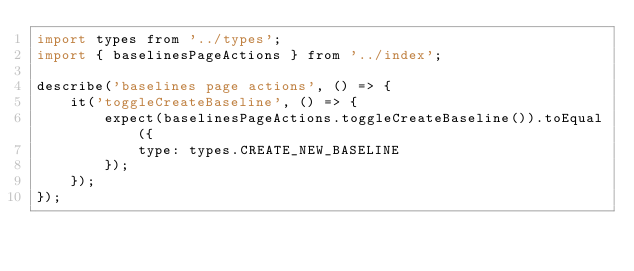<code> <loc_0><loc_0><loc_500><loc_500><_JavaScript_>import types from '../types';
import { baselinesPageActions } from '../index';

describe('baselines page actions', () => {
    it('toggleCreateBaseline', () => {
        expect(baselinesPageActions.toggleCreateBaseline()).toEqual({
            type: types.CREATE_NEW_BASELINE
        });
    });
});
</code> 